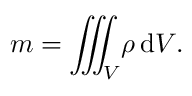<formula> <loc_0><loc_0><loc_500><loc_500>{ m } = { \iiint _ { V } \, \rho \, d V } .</formula> 